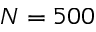Convert formula to latex. <formula><loc_0><loc_0><loc_500><loc_500>N = 5 0 0</formula> 